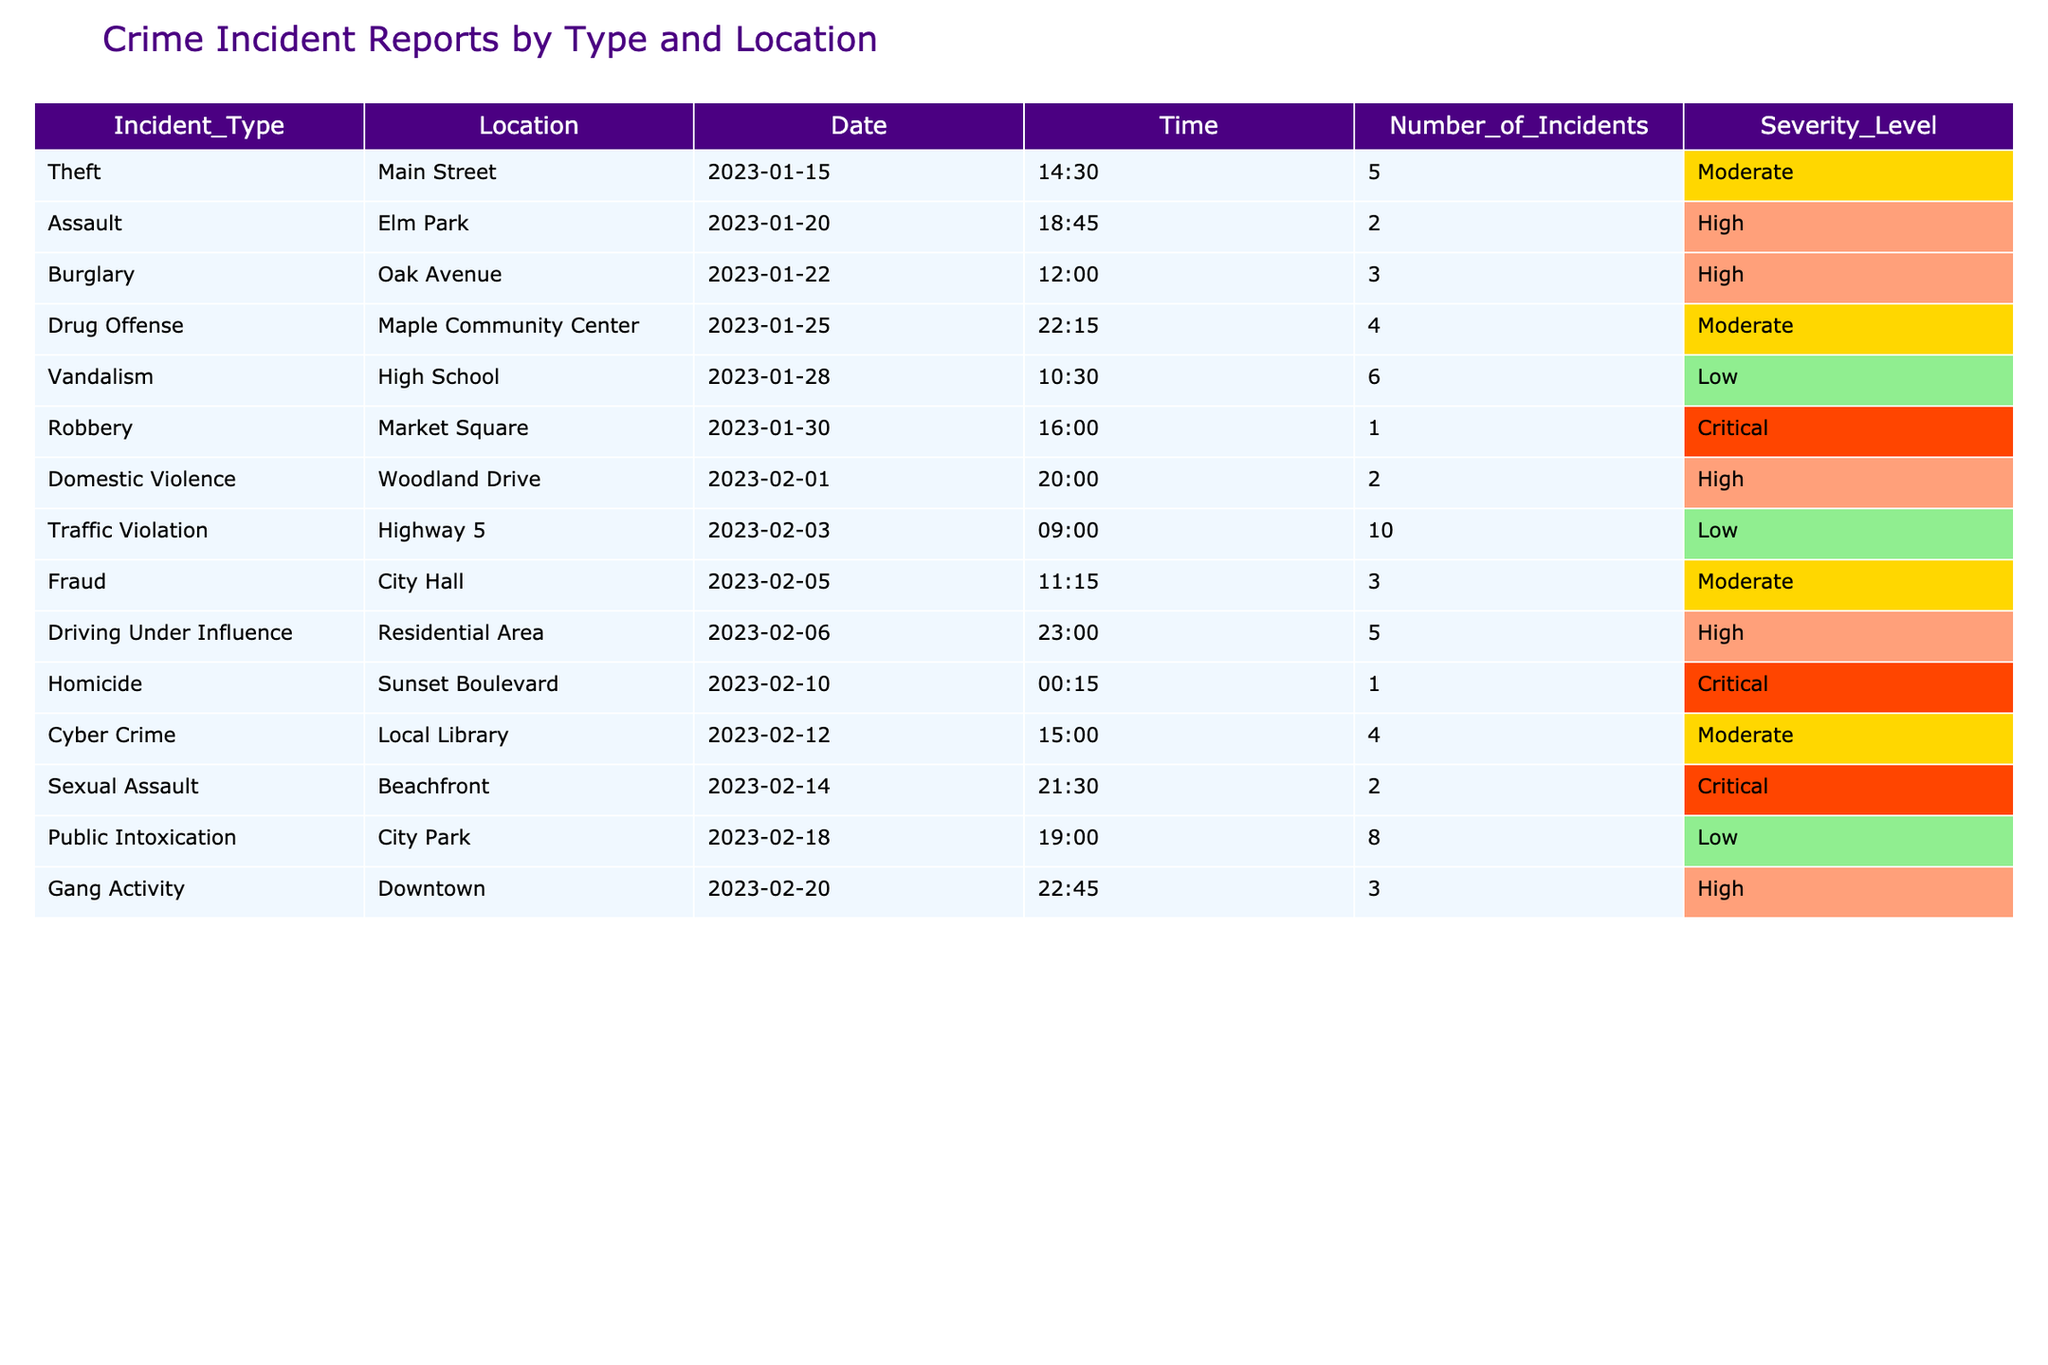What is the total number of incidents reported in Elm Park? The table shows that there are 2 incidents categorized as Assault in Elm Park. Therefore, the total number of incidents reported in that location is the same, which is 2.
Answer: 2 Which incident type recorded the highest number of incidents overall? Upon reviewing the table, the Traffic Violation on Highway 5 has the highest number of incidents with a total of 10 incidents reported.
Answer: Traffic Violation Are there any incidents reported with a "Critical" severity level? Yes, the table indicates there are 3 incidents with a "Critical" severity level: Robbery, Homicide, and Sexual Assault.
Answer: Yes What is the average number of incidents reported across all locations? To find the average, sum all the incidents (5 + 2 + 3 + 4 + 6 + 1 + 2 + 10 + 3 + 5 + 1 + 4 + 2 + 8 + 3 = 56) and divide by the number of incident types (15), resulting in an average of 56 / 15 ≈ 3.73.
Answer: Approximately 3.73 Which location had the maximum number of incidents, and what was the total number? After examining the data, Highway 5 had the maximum number of incidents with a total of 10.
Answer: Highway 5, 10 How many High severity incidents occurred in Oak Avenue? The table shows 3 incidents of Burglary in Oak Avenue with a "High" severity level.
Answer: 3 Is there any evidence of Gang Activity with a severity level of High or greater? Yes, the table confirms there are 3 incidents listed under Gang Activity, which is classified as "High" severity.
Answer: Yes What proportion of the incidents reported were classified as "Moderate" severity? From the data, there are 5 incidents categorized as "Moderate" out of a total of 15 incidents, resulting in a proportion of 5/15 = 1/3, which is approximately 33.33%.
Answer: Approximately 33.33% How many locations experienced incidents classified as "Low" severity? There are 3 locations featuring incidents classified as "Low" severity: High School (Vandalism), Highway 5 (Traffic Violation), and City Park (Public Intoxication).
Answer: 3 Which incident type recorded the least number of total incidents and what was that number? An analysis of the table shows Robbery, Homicide, and Sexual Assault each recorded 1 incident. Therefore, they are tied as the incident types with the least total incidents.
Answer: Robbery, Homicide, Sexual Assault, 1 each 